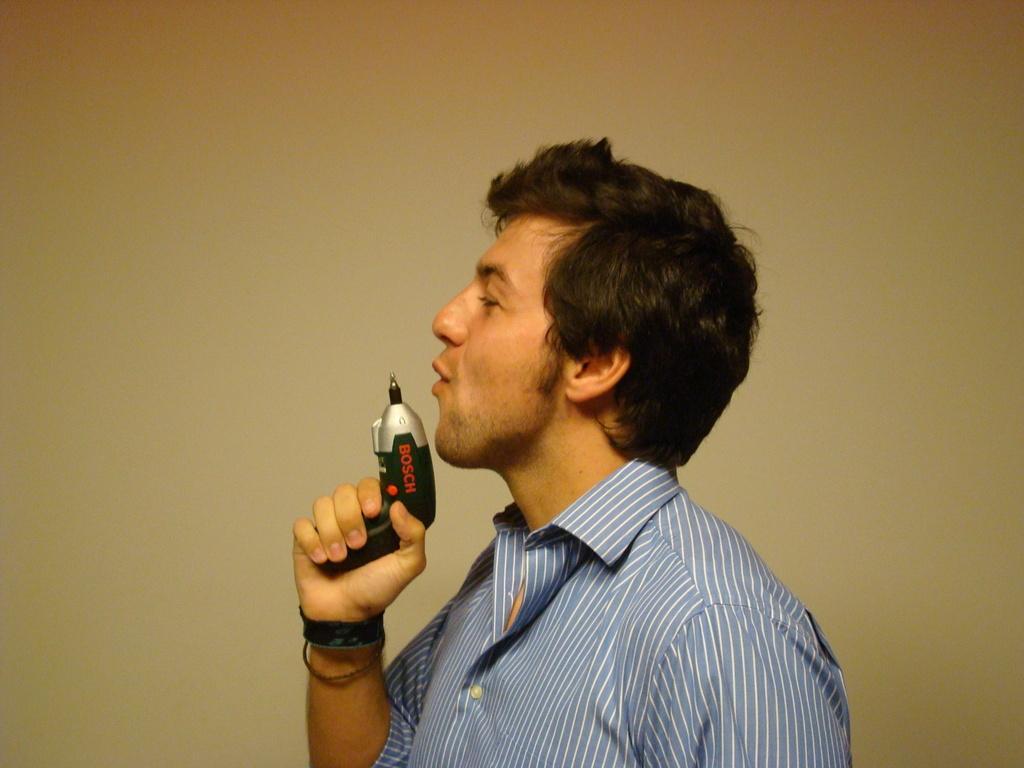In one or two sentences, can you explain what this image depicts? In this picture we can observe a person wearing a blue color shirt. He is holding a black color device in his hand. In the background there is a wall which is in yellow color. 